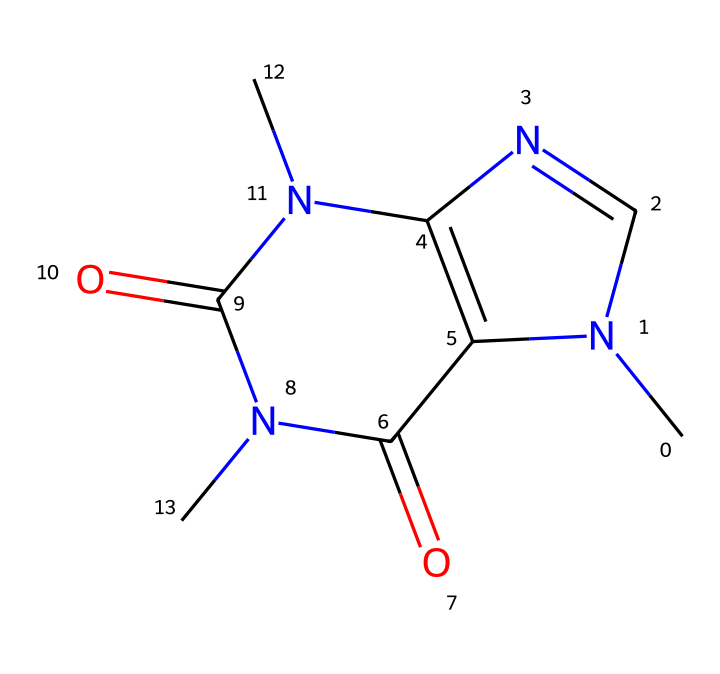What is the total number of nitrogen atoms in this caffeine structure? By analyzing the SMILES representation, we can identify that there are two nitrogen atoms present in the structure, indicated by the 'N' in the SMILES.
Answer: two How many carbon atoms are there in the caffeine structure? The SMILES representation contains six 'C' symbols, indicating the presence of six carbon atoms in the chemical structure of caffeine.
Answer: six What type of chemical bond is primarily found in this compound? Given the aromatic structure in caffeine, the dominant types of bonds include covalent bonds, which are present between carbon atoms and between carbon and nitrogen atoms.
Answer: covalent Is caffeine considered an aromatic compound? The structure contains a benzene ring-like arrangement due to the alternating single and double bonds, which makes caffeine aromatic.
Answer: yes How many cyclic components can be identified in this structure? The structure of caffeine reveals two cyclic groups when analyzed, as indicated by the ring closures in the SMILES notation.
Answer: two What functional groups are indicated in the caffeine structure? In this structure, there are amide functional groups present, as seen from the nitrogen connected to carbonyl (C=O) groups in the SMILES representation.
Answer: amide 